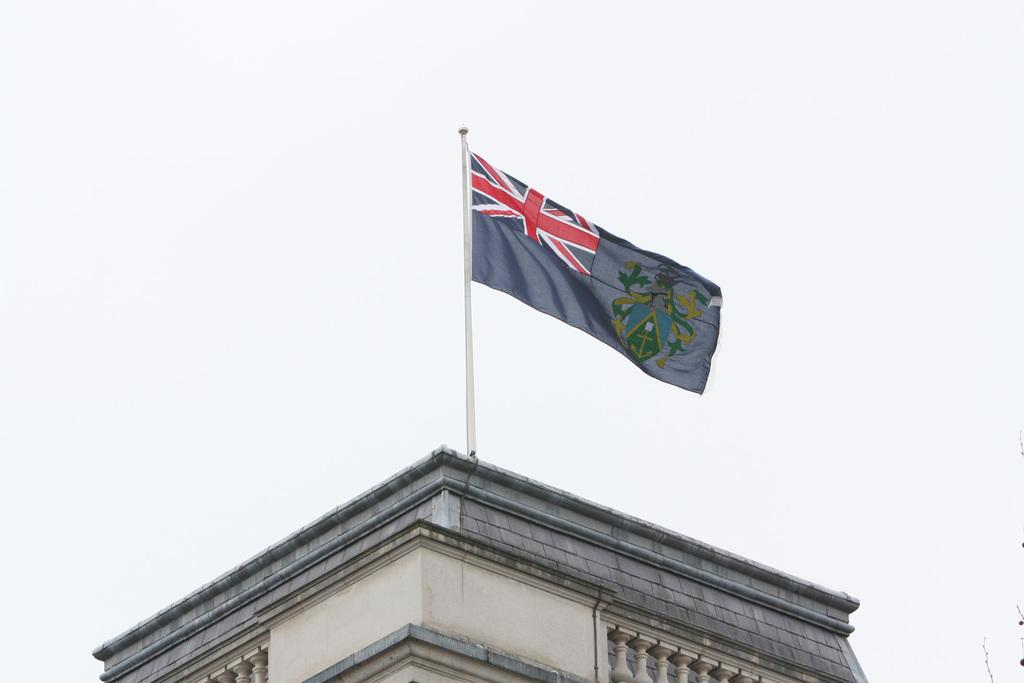What type of structure is present in the image? There is a building in the image. What can be seen flying near the building? There is a flag in the image. What is visible at the top of the image? The sky is visible at the top of the image. What type of curtain can be seen hanging in the building in the image? There is no curtain visible in the image; it only features a building and a flag. 